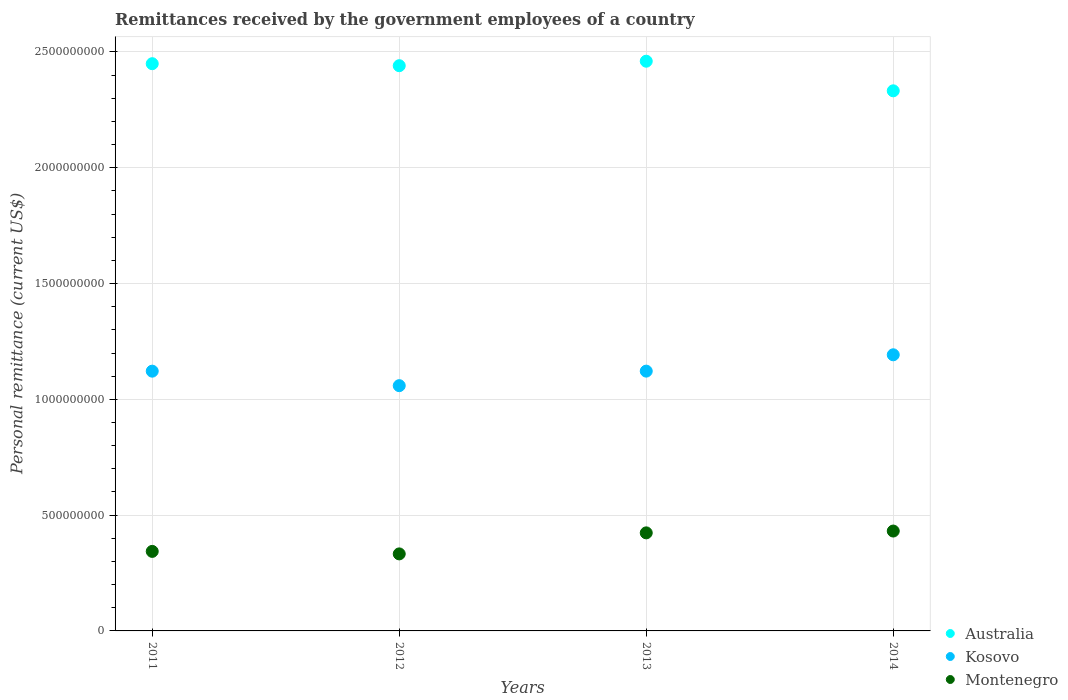How many different coloured dotlines are there?
Give a very brief answer. 3. Is the number of dotlines equal to the number of legend labels?
Offer a very short reply. Yes. What is the remittances received by the government employees in Australia in 2013?
Provide a succinct answer. 2.46e+09. Across all years, what is the maximum remittances received by the government employees in Montenegro?
Give a very brief answer. 4.31e+08. Across all years, what is the minimum remittances received by the government employees in Kosovo?
Provide a short and direct response. 1.06e+09. In which year was the remittances received by the government employees in Montenegro maximum?
Provide a succinct answer. 2014. What is the total remittances received by the government employees in Kosovo in the graph?
Give a very brief answer. 4.49e+09. What is the difference between the remittances received by the government employees in Australia in 2011 and that in 2012?
Make the answer very short. 8.65e+06. What is the difference between the remittances received by the government employees in Kosovo in 2013 and the remittances received by the government employees in Montenegro in 2014?
Provide a short and direct response. 6.91e+08. What is the average remittances received by the government employees in Montenegro per year?
Ensure brevity in your answer.  3.83e+08. In the year 2012, what is the difference between the remittances received by the government employees in Kosovo and remittances received by the government employees in Montenegro?
Your answer should be very brief. 7.26e+08. In how many years, is the remittances received by the government employees in Australia greater than 1700000000 US$?
Offer a very short reply. 4. What is the ratio of the remittances received by the government employees in Kosovo in 2011 to that in 2012?
Keep it short and to the point. 1.06. Is the difference between the remittances received by the government employees in Kosovo in 2011 and 2014 greater than the difference between the remittances received by the government employees in Montenegro in 2011 and 2014?
Provide a short and direct response. Yes. What is the difference between the highest and the second highest remittances received by the government employees in Montenegro?
Make the answer very short. 7.87e+06. What is the difference between the highest and the lowest remittances received by the government employees in Kosovo?
Provide a short and direct response. 1.33e+08. In how many years, is the remittances received by the government employees in Montenegro greater than the average remittances received by the government employees in Montenegro taken over all years?
Offer a terse response. 2. Is the sum of the remittances received by the government employees in Montenegro in 2011 and 2012 greater than the maximum remittances received by the government employees in Kosovo across all years?
Your answer should be very brief. No. Does the remittances received by the government employees in Kosovo monotonically increase over the years?
Provide a short and direct response. No. Are the values on the major ticks of Y-axis written in scientific E-notation?
Make the answer very short. No. Does the graph contain any zero values?
Your answer should be compact. No. Where does the legend appear in the graph?
Keep it short and to the point. Bottom right. How many legend labels are there?
Offer a terse response. 3. What is the title of the graph?
Your response must be concise. Remittances received by the government employees of a country. Does "Afghanistan" appear as one of the legend labels in the graph?
Offer a terse response. No. What is the label or title of the X-axis?
Give a very brief answer. Years. What is the label or title of the Y-axis?
Offer a very short reply. Personal remittance (current US$). What is the Personal remittance (current US$) of Australia in 2011?
Make the answer very short. 2.45e+09. What is the Personal remittance (current US$) in Kosovo in 2011?
Make the answer very short. 1.12e+09. What is the Personal remittance (current US$) of Montenegro in 2011?
Give a very brief answer. 3.43e+08. What is the Personal remittance (current US$) in Australia in 2012?
Your response must be concise. 2.44e+09. What is the Personal remittance (current US$) of Kosovo in 2012?
Offer a terse response. 1.06e+09. What is the Personal remittance (current US$) in Montenegro in 2012?
Provide a short and direct response. 3.33e+08. What is the Personal remittance (current US$) in Australia in 2013?
Ensure brevity in your answer.  2.46e+09. What is the Personal remittance (current US$) in Kosovo in 2013?
Your answer should be compact. 1.12e+09. What is the Personal remittance (current US$) of Montenegro in 2013?
Make the answer very short. 4.23e+08. What is the Personal remittance (current US$) of Australia in 2014?
Offer a very short reply. 2.33e+09. What is the Personal remittance (current US$) in Kosovo in 2014?
Make the answer very short. 1.19e+09. What is the Personal remittance (current US$) in Montenegro in 2014?
Give a very brief answer. 4.31e+08. Across all years, what is the maximum Personal remittance (current US$) in Australia?
Offer a terse response. 2.46e+09. Across all years, what is the maximum Personal remittance (current US$) in Kosovo?
Provide a short and direct response. 1.19e+09. Across all years, what is the maximum Personal remittance (current US$) of Montenegro?
Ensure brevity in your answer.  4.31e+08. Across all years, what is the minimum Personal remittance (current US$) in Australia?
Offer a terse response. 2.33e+09. Across all years, what is the minimum Personal remittance (current US$) in Kosovo?
Provide a short and direct response. 1.06e+09. Across all years, what is the minimum Personal remittance (current US$) in Montenegro?
Provide a succinct answer. 3.33e+08. What is the total Personal remittance (current US$) of Australia in the graph?
Give a very brief answer. 9.68e+09. What is the total Personal remittance (current US$) in Kosovo in the graph?
Keep it short and to the point. 4.49e+09. What is the total Personal remittance (current US$) of Montenegro in the graph?
Offer a very short reply. 1.53e+09. What is the difference between the Personal remittance (current US$) of Australia in 2011 and that in 2012?
Your answer should be compact. 8.65e+06. What is the difference between the Personal remittance (current US$) of Kosovo in 2011 and that in 2012?
Keep it short and to the point. 6.26e+07. What is the difference between the Personal remittance (current US$) of Montenegro in 2011 and that in 2012?
Your answer should be very brief. 1.08e+07. What is the difference between the Personal remittance (current US$) of Australia in 2011 and that in 2013?
Offer a very short reply. -1.07e+07. What is the difference between the Personal remittance (current US$) in Kosovo in 2011 and that in 2013?
Your response must be concise. -1.49e+05. What is the difference between the Personal remittance (current US$) in Montenegro in 2011 and that in 2013?
Give a very brief answer. -8.00e+07. What is the difference between the Personal remittance (current US$) in Australia in 2011 and that in 2014?
Make the answer very short. 1.17e+08. What is the difference between the Personal remittance (current US$) of Kosovo in 2011 and that in 2014?
Your answer should be compact. -7.07e+07. What is the difference between the Personal remittance (current US$) of Montenegro in 2011 and that in 2014?
Keep it short and to the point. -8.79e+07. What is the difference between the Personal remittance (current US$) of Australia in 2012 and that in 2013?
Your response must be concise. -1.94e+07. What is the difference between the Personal remittance (current US$) in Kosovo in 2012 and that in 2013?
Offer a terse response. -6.28e+07. What is the difference between the Personal remittance (current US$) of Montenegro in 2012 and that in 2013?
Ensure brevity in your answer.  -9.08e+07. What is the difference between the Personal remittance (current US$) in Australia in 2012 and that in 2014?
Provide a short and direct response. 1.08e+08. What is the difference between the Personal remittance (current US$) of Kosovo in 2012 and that in 2014?
Give a very brief answer. -1.33e+08. What is the difference between the Personal remittance (current US$) of Montenegro in 2012 and that in 2014?
Your answer should be very brief. -9.87e+07. What is the difference between the Personal remittance (current US$) in Australia in 2013 and that in 2014?
Keep it short and to the point. 1.28e+08. What is the difference between the Personal remittance (current US$) of Kosovo in 2013 and that in 2014?
Keep it short and to the point. -7.05e+07. What is the difference between the Personal remittance (current US$) of Montenegro in 2013 and that in 2014?
Your response must be concise. -7.87e+06. What is the difference between the Personal remittance (current US$) in Australia in 2011 and the Personal remittance (current US$) in Kosovo in 2012?
Provide a short and direct response. 1.39e+09. What is the difference between the Personal remittance (current US$) of Australia in 2011 and the Personal remittance (current US$) of Montenegro in 2012?
Offer a terse response. 2.12e+09. What is the difference between the Personal remittance (current US$) of Kosovo in 2011 and the Personal remittance (current US$) of Montenegro in 2012?
Ensure brevity in your answer.  7.89e+08. What is the difference between the Personal remittance (current US$) in Australia in 2011 and the Personal remittance (current US$) in Kosovo in 2013?
Ensure brevity in your answer.  1.33e+09. What is the difference between the Personal remittance (current US$) in Australia in 2011 and the Personal remittance (current US$) in Montenegro in 2013?
Provide a short and direct response. 2.03e+09. What is the difference between the Personal remittance (current US$) of Kosovo in 2011 and the Personal remittance (current US$) of Montenegro in 2013?
Provide a short and direct response. 6.98e+08. What is the difference between the Personal remittance (current US$) of Australia in 2011 and the Personal remittance (current US$) of Kosovo in 2014?
Offer a very short reply. 1.26e+09. What is the difference between the Personal remittance (current US$) of Australia in 2011 and the Personal remittance (current US$) of Montenegro in 2014?
Provide a short and direct response. 2.02e+09. What is the difference between the Personal remittance (current US$) in Kosovo in 2011 and the Personal remittance (current US$) in Montenegro in 2014?
Offer a terse response. 6.90e+08. What is the difference between the Personal remittance (current US$) of Australia in 2012 and the Personal remittance (current US$) of Kosovo in 2013?
Offer a very short reply. 1.32e+09. What is the difference between the Personal remittance (current US$) of Australia in 2012 and the Personal remittance (current US$) of Montenegro in 2013?
Your response must be concise. 2.02e+09. What is the difference between the Personal remittance (current US$) of Kosovo in 2012 and the Personal remittance (current US$) of Montenegro in 2013?
Your answer should be very brief. 6.36e+08. What is the difference between the Personal remittance (current US$) in Australia in 2012 and the Personal remittance (current US$) in Kosovo in 2014?
Your answer should be very brief. 1.25e+09. What is the difference between the Personal remittance (current US$) of Australia in 2012 and the Personal remittance (current US$) of Montenegro in 2014?
Your answer should be very brief. 2.01e+09. What is the difference between the Personal remittance (current US$) of Kosovo in 2012 and the Personal remittance (current US$) of Montenegro in 2014?
Your answer should be very brief. 6.28e+08. What is the difference between the Personal remittance (current US$) in Australia in 2013 and the Personal remittance (current US$) in Kosovo in 2014?
Provide a short and direct response. 1.27e+09. What is the difference between the Personal remittance (current US$) of Australia in 2013 and the Personal remittance (current US$) of Montenegro in 2014?
Provide a succinct answer. 2.03e+09. What is the difference between the Personal remittance (current US$) in Kosovo in 2013 and the Personal remittance (current US$) in Montenegro in 2014?
Make the answer very short. 6.91e+08. What is the average Personal remittance (current US$) in Australia per year?
Provide a succinct answer. 2.42e+09. What is the average Personal remittance (current US$) in Kosovo per year?
Keep it short and to the point. 1.12e+09. What is the average Personal remittance (current US$) of Montenegro per year?
Your response must be concise. 3.83e+08. In the year 2011, what is the difference between the Personal remittance (current US$) in Australia and Personal remittance (current US$) in Kosovo?
Make the answer very short. 1.33e+09. In the year 2011, what is the difference between the Personal remittance (current US$) of Australia and Personal remittance (current US$) of Montenegro?
Your response must be concise. 2.11e+09. In the year 2011, what is the difference between the Personal remittance (current US$) of Kosovo and Personal remittance (current US$) of Montenegro?
Offer a terse response. 7.78e+08. In the year 2012, what is the difference between the Personal remittance (current US$) of Australia and Personal remittance (current US$) of Kosovo?
Make the answer very short. 1.38e+09. In the year 2012, what is the difference between the Personal remittance (current US$) in Australia and Personal remittance (current US$) in Montenegro?
Provide a succinct answer. 2.11e+09. In the year 2012, what is the difference between the Personal remittance (current US$) in Kosovo and Personal remittance (current US$) in Montenegro?
Offer a very short reply. 7.26e+08. In the year 2013, what is the difference between the Personal remittance (current US$) of Australia and Personal remittance (current US$) of Kosovo?
Your answer should be very brief. 1.34e+09. In the year 2013, what is the difference between the Personal remittance (current US$) in Australia and Personal remittance (current US$) in Montenegro?
Keep it short and to the point. 2.04e+09. In the year 2013, what is the difference between the Personal remittance (current US$) in Kosovo and Personal remittance (current US$) in Montenegro?
Your answer should be very brief. 6.98e+08. In the year 2014, what is the difference between the Personal remittance (current US$) of Australia and Personal remittance (current US$) of Kosovo?
Your answer should be compact. 1.14e+09. In the year 2014, what is the difference between the Personal remittance (current US$) of Australia and Personal remittance (current US$) of Montenegro?
Ensure brevity in your answer.  1.90e+09. In the year 2014, what is the difference between the Personal remittance (current US$) of Kosovo and Personal remittance (current US$) of Montenegro?
Make the answer very short. 7.61e+08. What is the ratio of the Personal remittance (current US$) of Australia in 2011 to that in 2012?
Ensure brevity in your answer.  1. What is the ratio of the Personal remittance (current US$) of Kosovo in 2011 to that in 2012?
Your response must be concise. 1.06. What is the ratio of the Personal remittance (current US$) in Montenegro in 2011 to that in 2012?
Your answer should be compact. 1.03. What is the ratio of the Personal remittance (current US$) in Australia in 2011 to that in 2013?
Your response must be concise. 1. What is the ratio of the Personal remittance (current US$) of Montenegro in 2011 to that in 2013?
Your answer should be compact. 0.81. What is the ratio of the Personal remittance (current US$) of Australia in 2011 to that in 2014?
Your answer should be very brief. 1.05. What is the ratio of the Personal remittance (current US$) of Kosovo in 2011 to that in 2014?
Ensure brevity in your answer.  0.94. What is the ratio of the Personal remittance (current US$) of Montenegro in 2011 to that in 2014?
Your response must be concise. 0.8. What is the ratio of the Personal remittance (current US$) in Kosovo in 2012 to that in 2013?
Give a very brief answer. 0.94. What is the ratio of the Personal remittance (current US$) in Montenegro in 2012 to that in 2013?
Keep it short and to the point. 0.79. What is the ratio of the Personal remittance (current US$) in Australia in 2012 to that in 2014?
Provide a succinct answer. 1.05. What is the ratio of the Personal remittance (current US$) in Kosovo in 2012 to that in 2014?
Make the answer very short. 0.89. What is the ratio of the Personal remittance (current US$) in Montenegro in 2012 to that in 2014?
Provide a short and direct response. 0.77. What is the ratio of the Personal remittance (current US$) in Australia in 2013 to that in 2014?
Give a very brief answer. 1.05. What is the ratio of the Personal remittance (current US$) in Kosovo in 2013 to that in 2014?
Ensure brevity in your answer.  0.94. What is the ratio of the Personal remittance (current US$) in Montenegro in 2013 to that in 2014?
Your answer should be very brief. 0.98. What is the difference between the highest and the second highest Personal remittance (current US$) in Australia?
Your answer should be very brief. 1.07e+07. What is the difference between the highest and the second highest Personal remittance (current US$) in Kosovo?
Your answer should be compact. 7.05e+07. What is the difference between the highest and the second highest Personal remittance (current US$) in Montenegro?
Provide a succinct answer. 7.87e+06. What is the difference between the highest and the lowest Personal remittance (current US$) in Australia?
Give a very brief answer. 1.28e+08. What is the difference between the highest and the lowest Personal remittance (current US$) of Kosovo?
Your answer should be compact. 1.33e+08. What is the difference between the highest and the lowest Personal remittance (current US$) in Montenegro?
Make the answer very short. 9.87e+07. 